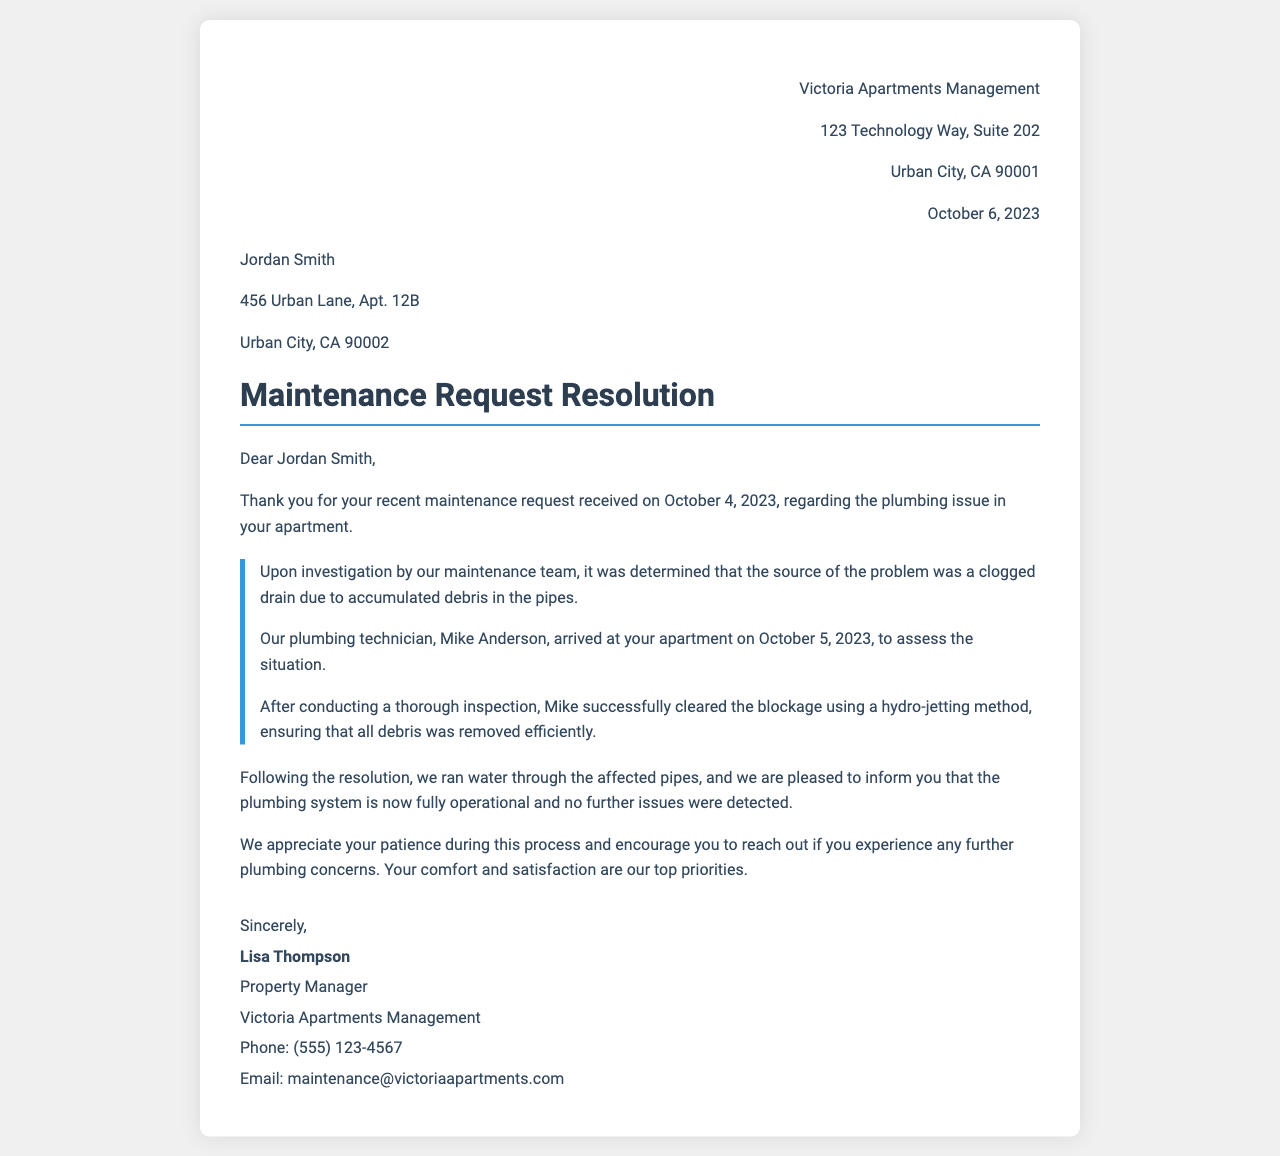What was the date of the maintenance request? The date of the maintenance request was explicitly mentioned in the document as October 4, 2023.
Answer: October 4, 2023 Who performed the plumbing assessment? The document specifies that the plumbing technician who assessed the situation was Mike Anderson.
Answer: Mike Anderson What method was used to clear the blockage? The resolution details that the blockage was cleared using a hydro-jetting method.
Answer: hydro-jetting What is the name of the property manager? The document states that the property manager's name is Lisa Thompson.
Answer: Lisa Thompson What is the phone number for maintenance inquiries? The document provides the phone number for maintenance inquiries as (555) 123-4567.
Answer: (555) 123-4567 Why did the maintenance team arrive at the apartment? The maintenance team arrived to address the plumbing issue related to a clogged drain due to accumulated debris.
Answer: clogged drain What was the final outcome after the plumbing work? The letter concludes that the plumbing system is now fully operational with no further issues detected.
Answer: fully operational When did the plumbing technician visit the apartment? The document indicates that the plumbing technician visited the apartment on October 5, 2023.
Answer: October 5, 2023 What is the email address for maintenance inquiries? The email address provided in the document for maintenance inquiries is maintenance@victoriaapartments.com.
Answer: maintenance@victoriaapartments.com 